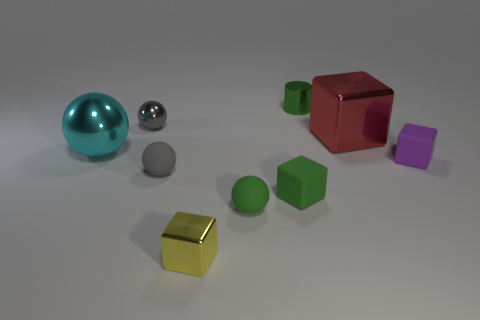There is a small cube that is the same color as the small metallic cylinder; what material is it?
Offer a terse response. Rubber. Is the color of the tiny shiny ball the same as the shiny block behind the tiny yellow thing?
Provide a succinct answer. No. The large red shiny object is what shape?
Make the answer very short. Cube. There is a gray ball behind the tiny gray thing in front of the small cube on the right side of the red object; what size is it?
Provide a succinct answer. Small. What number of other objects are there of the same shape as the purple rubber thing?
Offer a terse response. 3. Is the shape of the tiny rubber object that is to the left of the small yellow shiny object the same as the big thing behind the cyan metallic thing?
Provide a short and direct response. No. What number of cubes are either small purple matte things or large objects?
Keep it short and to the point. 2. There is a object behind the gray ball that is to the left of the tiny gray object in front of the tiny gray metallic sphere; what is it made of?
Ensure brevity in your answer.  Metal. What number of other things are there of the same size as the purple rubber cube?
Make the answer very short. 6. The matte block that is the same color as the shiny cylinder is what size?
Your answer should be compact. Small. 